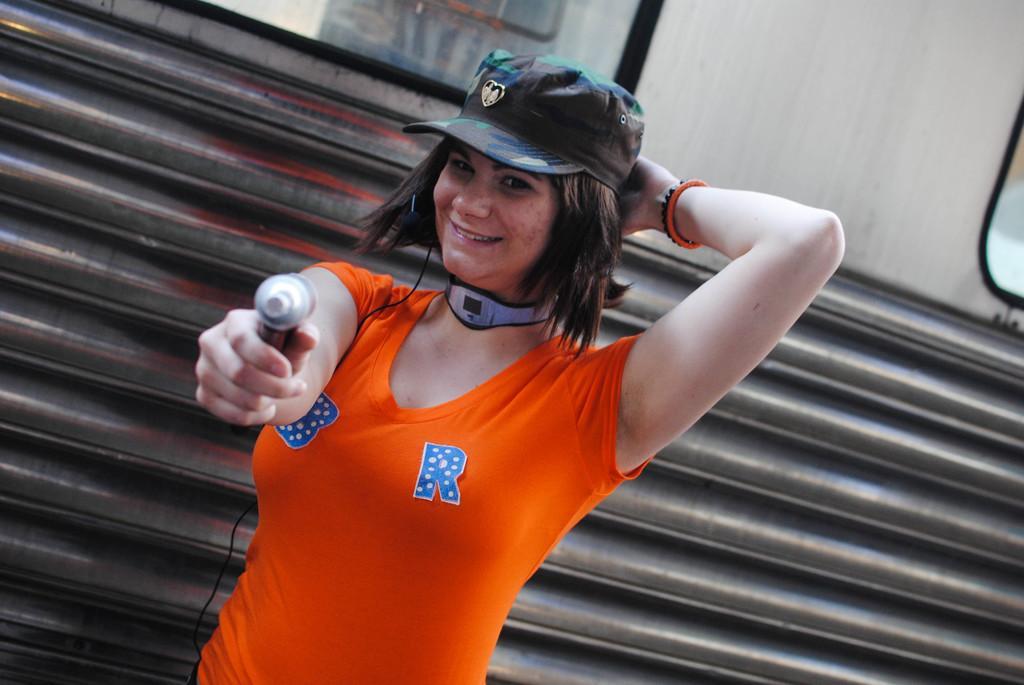Please provide a concise description of this image. Here in this picture we can see a woman standing over a place and she is holding something in her hand and smiling and we can see she is wearing cap on her and behind her we can see a train present over there. 